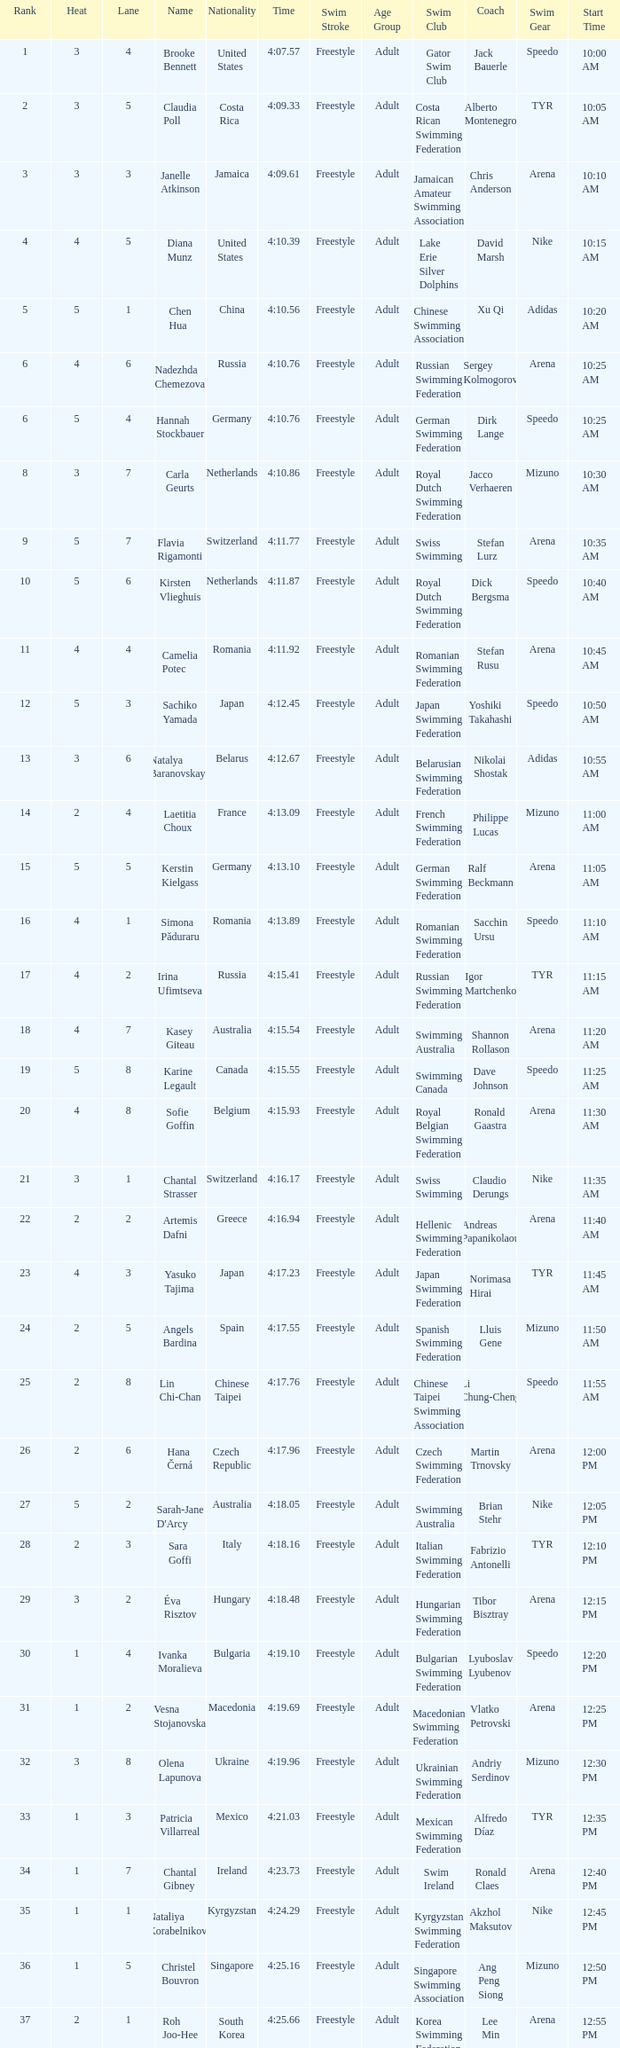Name the average rank with larger than 3 and heat more than 5 None. 